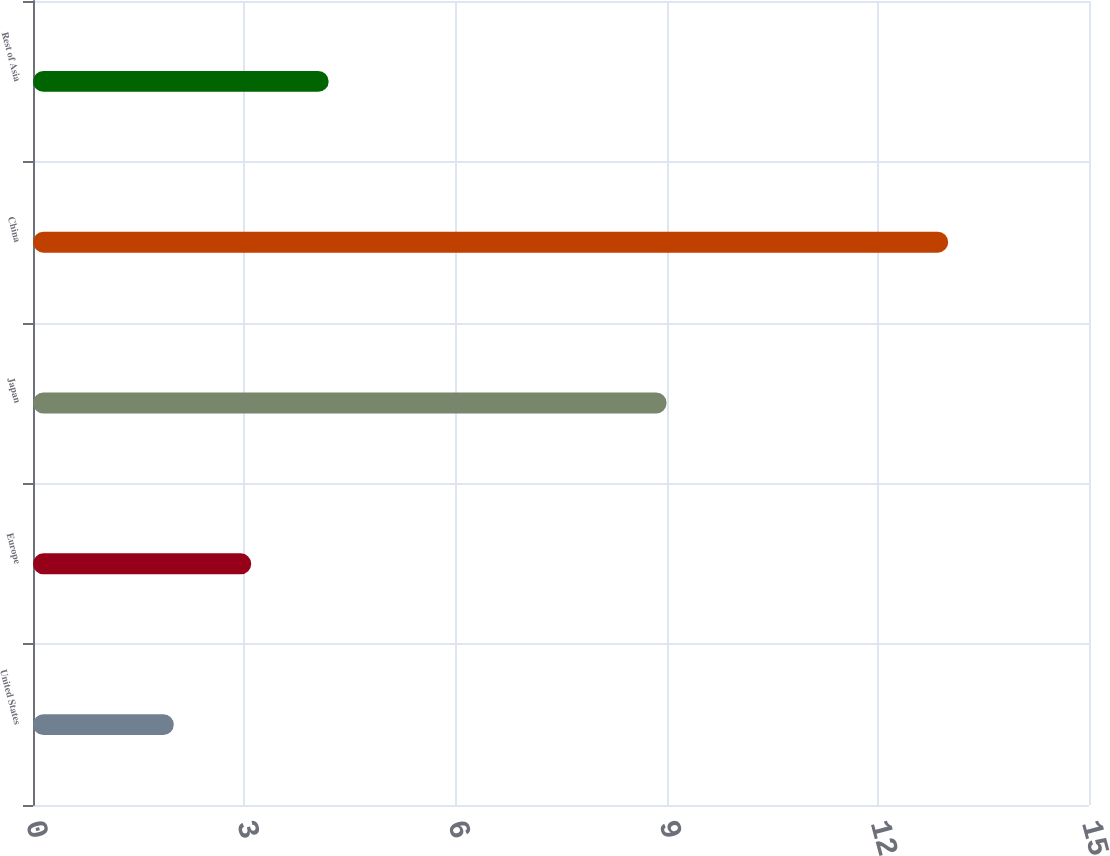<chart> <loc_0><loc_0><loc_500><loc_500><bar_chart><fcel>United States<fcel>Europe<fcel>Japan<fcel>China<fcel>Rest of Asia<nl><fcel>2<fcel>3.1<fcel>9<fcel>13<fcel>4.2<nl></chart> 